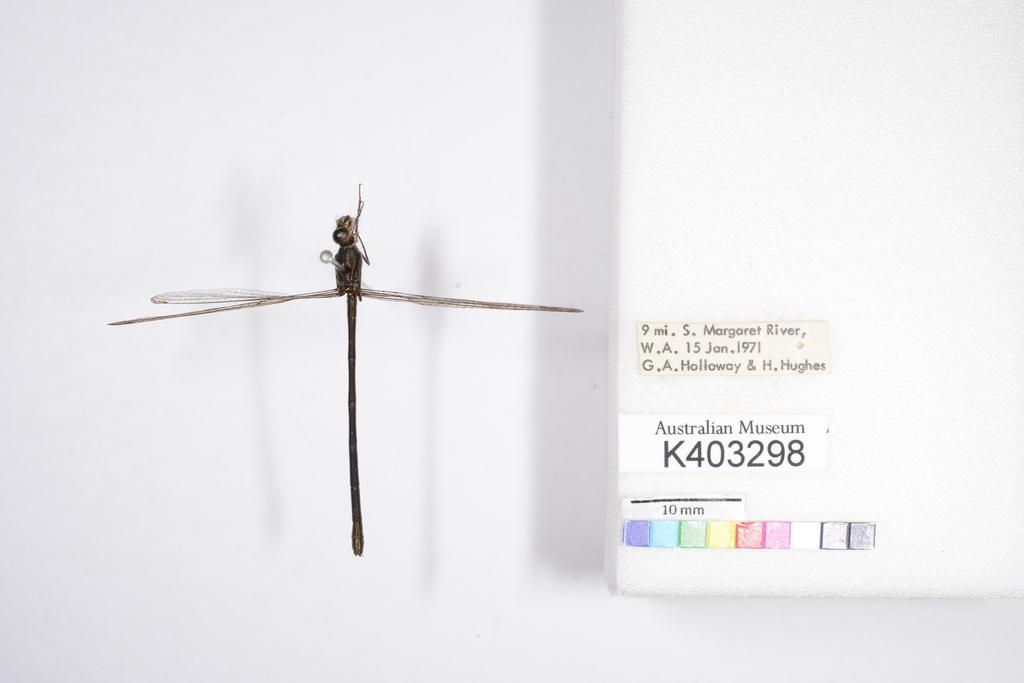What type of creature can be seen in the image? There is an insect in the image. What color is the prominent object in the image? There is a white color object in the image. What is attached to the white color object? Stickers are attached to the white color object. What is the color of the background in the image? The background of the image is white. Can you explain the theory behind the quicksand in the image? There is no quicksand present in the image, so it is not possible to explain a theory related to it. 